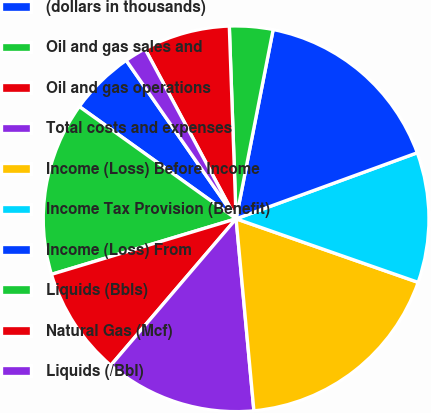<chart> <loc_0><loc_0><loc_500><loc_500><pie_chart><fcel>(dollars in thousands)<fcel>Oil and gas sales and<fcel>Oil and gas operations<fcel>Total costs and expenses<fcel>Income (Loss) Before Income<fcel>Income Tax Provision (Benefit)<fcel>Income (Loss) From<fcel>Liquids (Bbls)<fcel>Natural Gas (Mcf)<fcel>Liquids (/Bbl)<nl><fcel>5.46%<fcel>14.54%<fcel>9.09%<fcel>12.73%<fcel>18.18%<fcel>10.91%<fcel>16.36%<fcel>3.64%<fcel>7.27%<fcel>1.82%<nl></chart> 